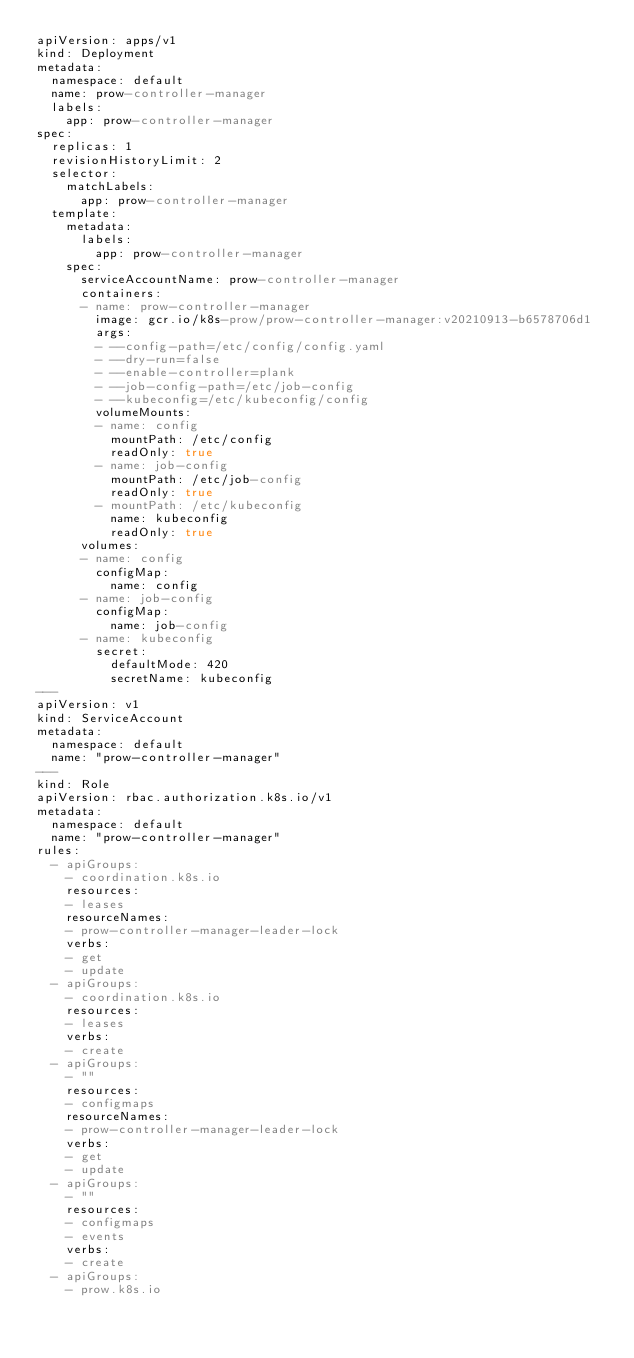<code> <loc_0><loc_0><loc_500><loc_500><_YAML_>apiVersion: apps/v1
kind: Deployment
metadata:
  namespace: default
  name: prow-controller-manager
  labels:
    app: prow-controller-manager
spec:
  replicas: 1
  revisionHistoryLimit: 2
  selector:
    matchLabels:
      app: prow-controller-manager
  template:
    metadata:
      labels:
        app: prow-controller-manager
    spec:
      serviceAccountName: prow-controller-manager
      containers:
      - name: prow-controller-manager
        image: gcr.io/k8s-prow/prow-controller-manager:v20210913-b6578706d1
        args:
        - --config-path=/etc/config/config.yaml
        - --dry-run=false
        - --enable-controller=plank
        - --job-config-path=/etc/job-config
        - --kubeconfig=/etc/kubeconfig/config
        volumeMounts:
        - name: config
          mountPath: /etc/config
          readOnly: true
        - name: job-config
          mountPath: /etc/job-config
          readOnly: true
        - mountPath: /etc/kubeconfig
          name: kubeconfig
          readOnly: true
      volumes:
      - name: config
        configMap:
          name: config
      - name: job-config
        configMap:
          name: job-config
      - name: kubeconfig
        secret:
          defaultMode: 420
          secretName: kubeconfig
---
apiVersion: v1
kind: ServiceAccount
metadata:
  namespace: default
  name: "prow-controller-manager"
---
kind: Role
apiVersion: rbac.authorization.k8s.io/v1
metadata:
  namespace: default
  name: "prow-controller-manager"
rules:
  - apiGroups:
    - coordination.k8s.io
    resources:
    - leases
    resourceNames:
    - prow-controller-manager-leader-lock
    verbs:
    - get
    - update
  - apiGroups:
    - coordination.k8s.io
    resources:
    - leases
    verbs:
    - create
  - apiGroups:
    - ""
    resources:
    - configmaps
    resourceNames:
    - prow-controller-manager-leader-lock
    verbs:
    - get
    - update
  - apiGroups:
    - ""
    resources:
    - configmaps
    - events
    verbs:
    - create
  - apiGroups:
    - prow.k8s.io</code> 